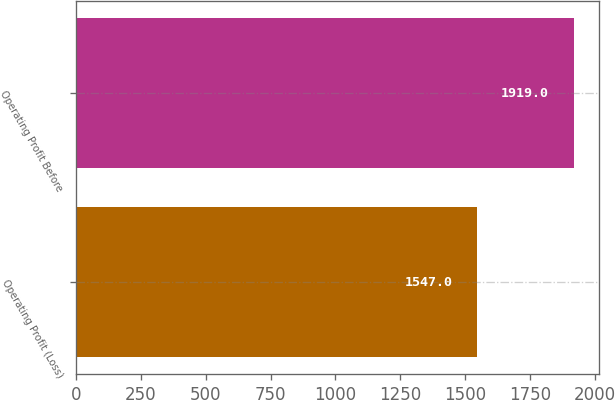Convert chart. <chart><loc_0><loc_0><loc_500><loc_500><bar_chart><fcel>Operating Profit (Loss)<fcel>Operating Profit Before<nl><fcel>1547<fcel>1919<nl></chart> 